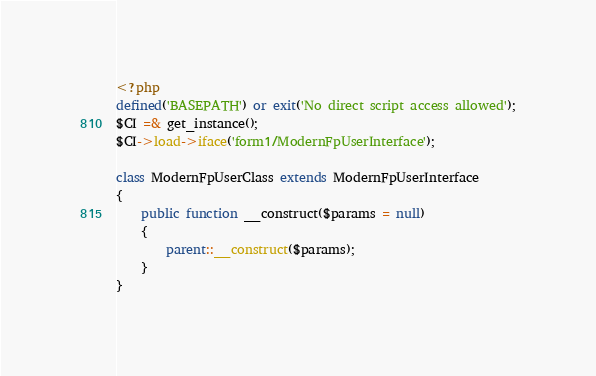Convert code to text. <code><loc_0><loc_0><loc_500><loc_500><_PHP_><?php
defined('BASEPATH') or exit('No direct script access allowed');
$CI =& get_instance();
$CI->load->iface('form1/ModernFpUserInterface');

class ModernFpUserClass extends ModernFpUserInterface
{
    public function __construct($params = null)
    {
        parent::__construct($params);
    }
}
</code> 